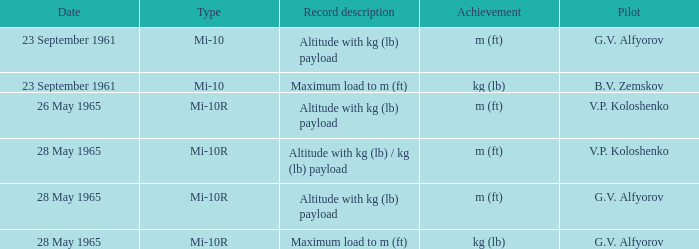Achievement of m (ft), and a Type of mi-10r, and a Pilot of v.p. koloshenko, and a Date of 28 may 1965 had what record description? Altitude with kg (lb) / kg (lb) payload. 